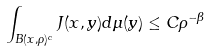Convert formula to latex. <formula><loc_0><loc_0><loc_500><loc_500>\int _ { B ( x , \rho ) ^ { c } } J ( x , y ) d \mu ( y ) \leq C \rho ^ { - \beta }</formula> 